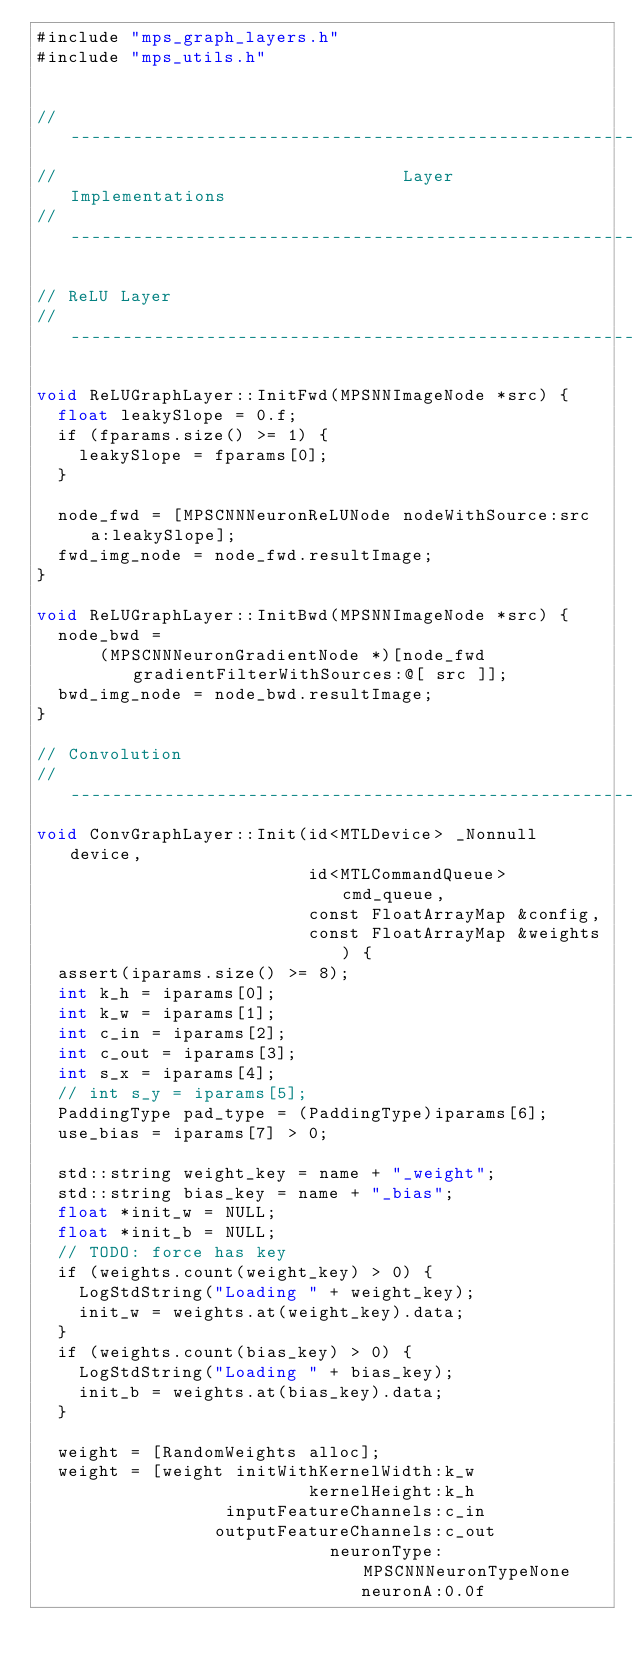Convert code to text. <code><loc_0><loc_0><loc_500><loc_500><_ObjectiveC_>#include "mps_graph_layers.h"
#include "mps_utils.h"


// --------------------------------------------------------------------------------------------
//                                 Layer Implementations
// --------------------------------------------------------------------------------------------

// ReLU Layer
// ------------------------------------------------------------------------------------

void ReLUGraphLayer::InitFwd(MPSNNImageNode *src) {
  float leakySlope = 0.f;
  if (fparams.size() >= 1) {
    leakySlope = fparams[0];
  }
  
  node_fwd = [MPSCNNNeuronReLUNode nodeWithSource:src a:leakySlope];
  fwd_img_node = node_fwd.resultImage;
}

void ReLUGraphLayer::InitBwd(MPSNNImageNode *src) {
  node_bwd =
      (MPSCNNNeuronGradientNode *)[node_fwd gradientFilterWithSources:@[ src ]];
  bwd_img_node = node_bwd.resultImage;
}

// Convolution
// ------------------------------------------------------------------------------------
void ConvGraphLayer::Init(id<MTLDevice> _Nonnull device,
                          id<MTLCommandQueue> cmd_queue,
                          const FloatArrayMap &config,
                          const FloatArrayMap &weights) {
  assert(iparams.size() >= 8);
  int k_h = iparams[0];
  int k_w = iparams[1];
  int c_in = iparams[2];
  int c_out = iparams[3];
  int s_x = iparams[4];
  // int s_y = iparams[5];
  PaddingType pad_type = (PaddingType)iparams[6];
  use_bias = iparams[7] > 0;

  std::string weight_key = name + "_weight";
  std::string bias_key = name + "_bias";
  float *init_w = NULL;
  float *init_b = NULL;
  // TODO: force has key
  if (weights.count(weight_key) > 0) {
    LogStdString("Loading " + weight_key);
    init_w = weights.at(weight_key).data;
  }
  if (weights.count(bias_key) > 0) {
    LogStdString("Loading " + bias_key);
    init_b = weights.at(bias_key).data;
  }

  weight = [RandomWeights alloc];
  weight = [weight initWithKernelWidth:k_w
                          kernelHeight:k_h
                  inputFeatureChannels:c_in
                 outputFeatureChannels:c_out
                            neuronType:MPSCNNNeuronTypeNone
                               neuronA:0.0f</code> 